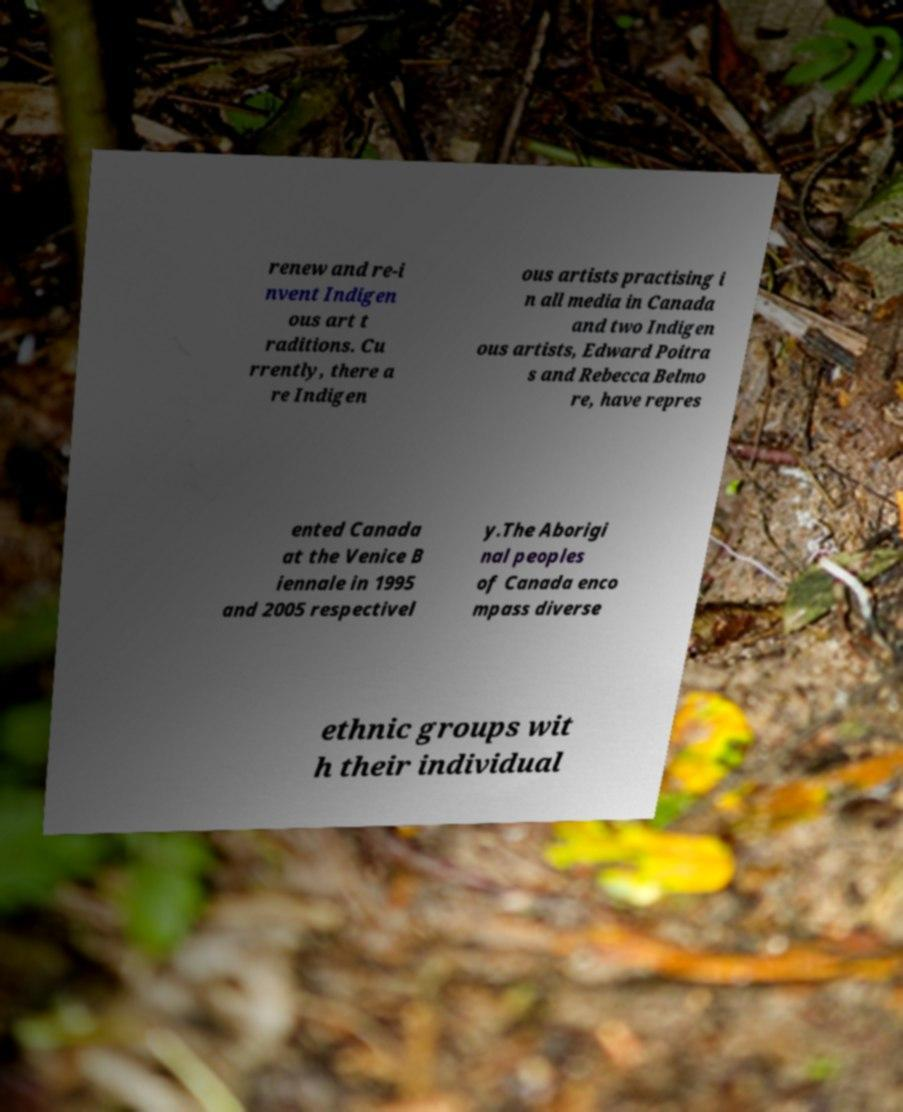Could you assist in decoding the text presented in this image and type it out clearly? renew and re-i nvent Indigen ous art t raditions. Cu rrently, there a re Indigen ous artists practising i n all media in Canada and two Indigen ous artists, Edward Poitra s and Rebecca Belmo re, have repres ented Canada at the Venice B iennale in 1995 and 2005 respectivel y.The Aborigi nal peoples of Canada enco mpass diverse ethnic groups wit h their individual 